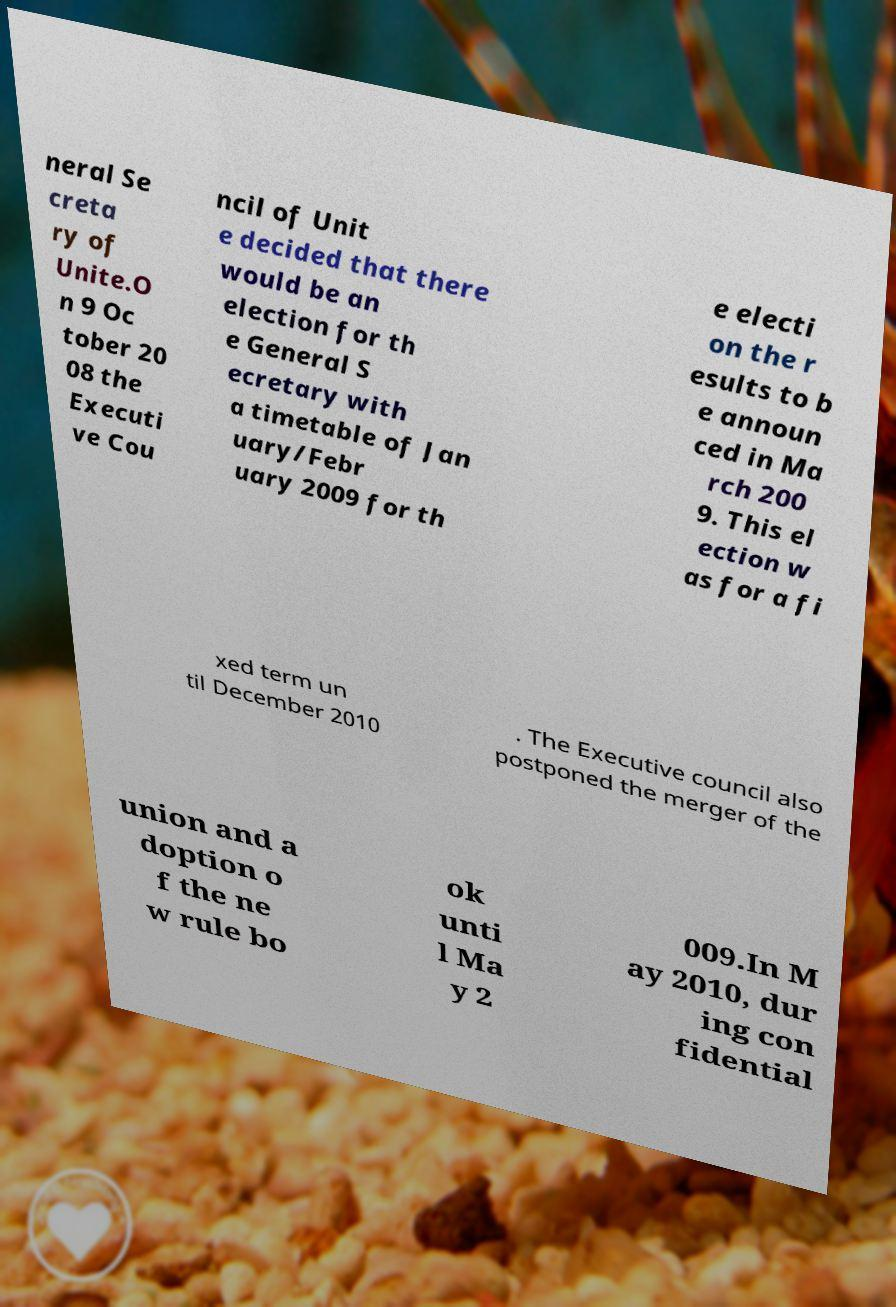Could you extract and type out the text from this image? neral Se creta ry of Unite.O n 9 Oc tober 20 08 the Executi ve Cou ncil of Unit e decided that there would be an election for th e General S ecretary with a timetable of Jan uary/Febr uary 2009 for th e electi on the r esults to b e announ ced in Ma rch 200 9. This el ection w as for a fi xed term un til December 2010 . The Executive council also postponed the merger of the union and a doption o f the ne w rule bo ok unti l Ma y 2 009.In M ay 2010, dur ing con fidential 